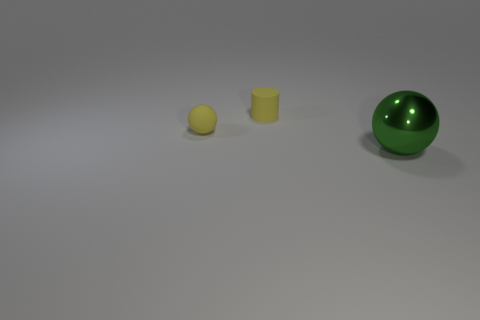Add 2 tiny metallic blocks. How many objects exist? 5 Subtract all cylinders. How many objects are left? 2 Subtract all small cylinders. Subtract all cyan cylinders. How many objects are left? 2 Add 1 big green shiny objects. How many big green shiny objects are left? 2 Add 2 purple objects. How many purple objects exist? 2 Subtract 0 purple cylinders. How many objects are left? 3 